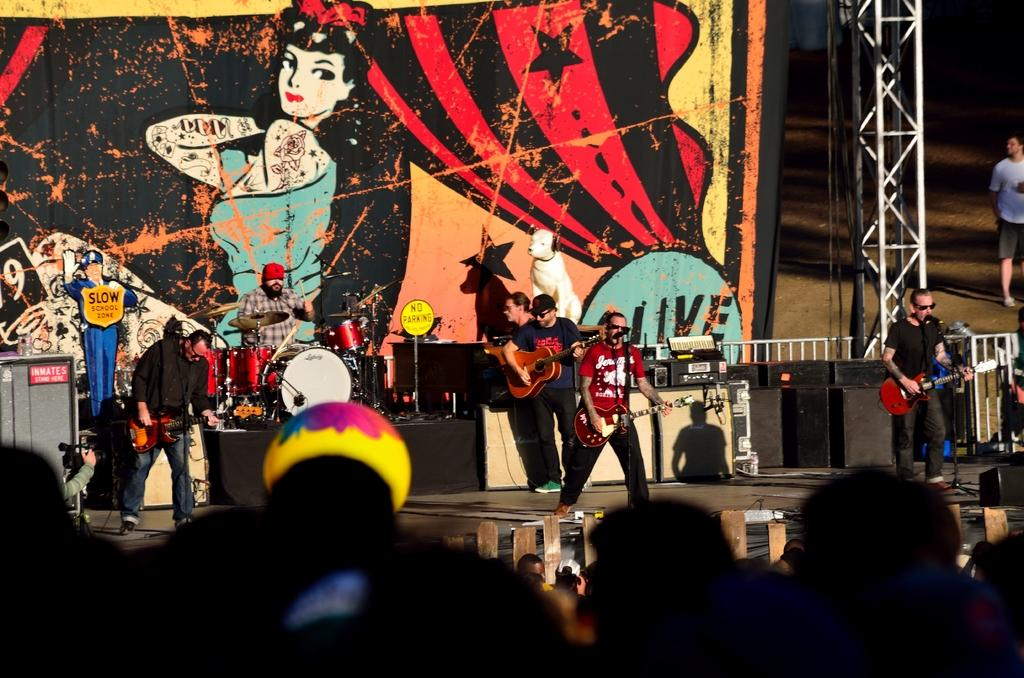What object can be seen in the image that is used for electricity? There is a current pole in the image. What are the people on stage doing? The people on stage are holding guitars. What other musical instrument is present in the image? There are musical drums in the image. Can you see a wren perched on the current pole in the image? There is no wren present in the image; it features a current pole, people on stage with guitars, and musical drums. Is there a bath visible in the image? There is no bath present in the image. 